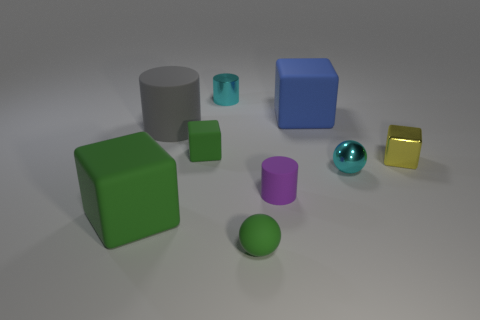Is the tiny matte cube the same color as the matte ball?
Your answer should be compact. Yes. Is there any other thing that is the same color as the shiny cube?
Keep it short and to the point. No. What is the color of the small sphere that is to the left of the big blue object?
Your response must be concise. Green. There is a small ball in front of the purple matte cylinder; does it have the same color as the small matte block?
Your response must be concise. Yes. There is a cyan thing that is the same shape as the tiny purple matte thing; what material is it?
Give a very brief answer. Metal. What number of gray rubber things are the same size as the yellow metallic cube?
Keep it short and to the point. 0. What is the shape of the big gray object?
Your answer should be very brief. Cylinder. How big is the object that is behind the gray cylinder and in front of the tiny shiny cylinder?
Keep it short and to the point. Large. There is a gray cylinder that is behind the purple matte cylinder; what is it made of?
Your response must be concise. Rubber. There is a tiny metallic cylinder; is it the same color as the sphere right of the green sphere?
Your answer should be very brief. Yes. 